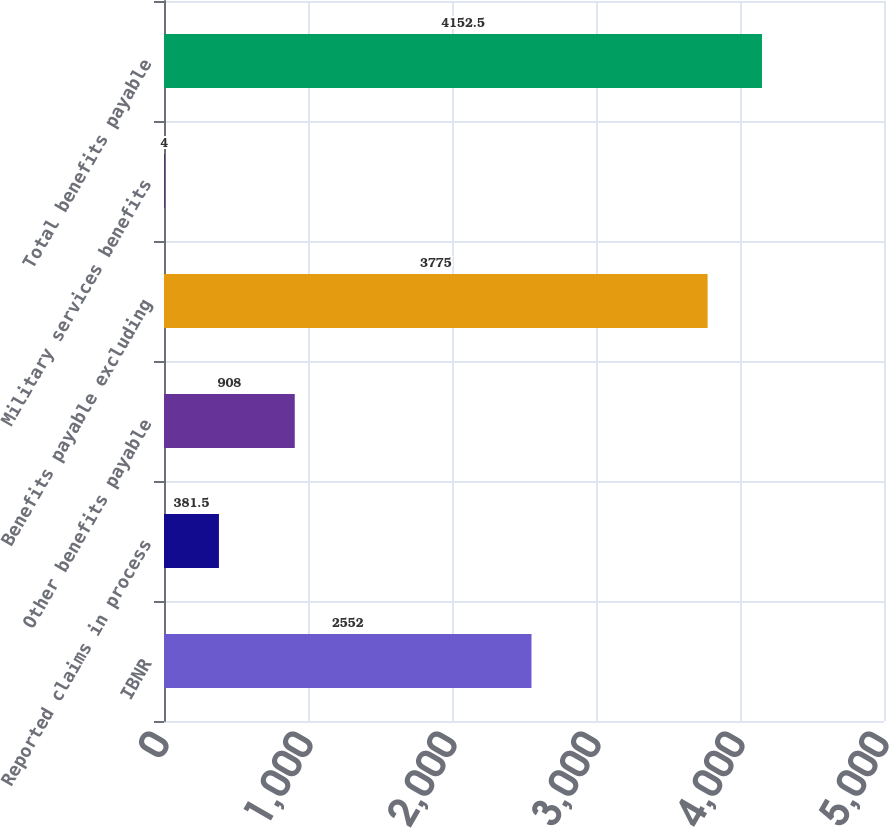Convert chart to OTSL. <chart><loc_0><loc_0><loc_500><loc_500><bar_chart><fcel>IBNR<fcel>Reported claims in process<fcel>Other benefits payable<fcel>Benefits payable excluding<fcel>Military services benefits<fcel>Total benefits payable<nl><fcel>2552<fcel>381.5<fcel>908<fcel>3775<fcel>4<fcel>4152.5<nl></chart> 